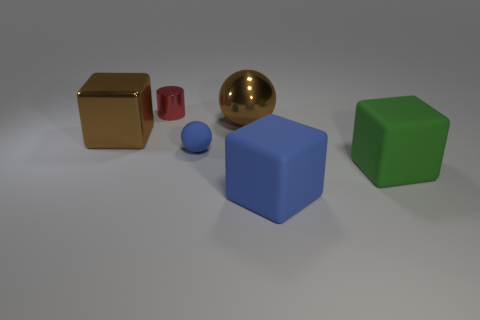Subtract all green matte cubes. How many cubes are left? 2 Add 2 metallic spheres. How many objects exist? 8 Subtract all blue cubes. How many cubes are left? 2 Subtract 1 balls. How many balls are left? 1 Subtract all cylinders. How many objects are left? 5 Subtract all gray blocks. How many purple cylinders are left? 0 Subtract all big cubes. Subtract all blue objects. How many objects are left? 1 Add 6 large green objects. How many large green objects are left? 7 Add 1 tiny yellow rubber balls. How many tiny yellow rubber balls exist? 1 Subtract 0 green spheres. How many objects are left? 6 